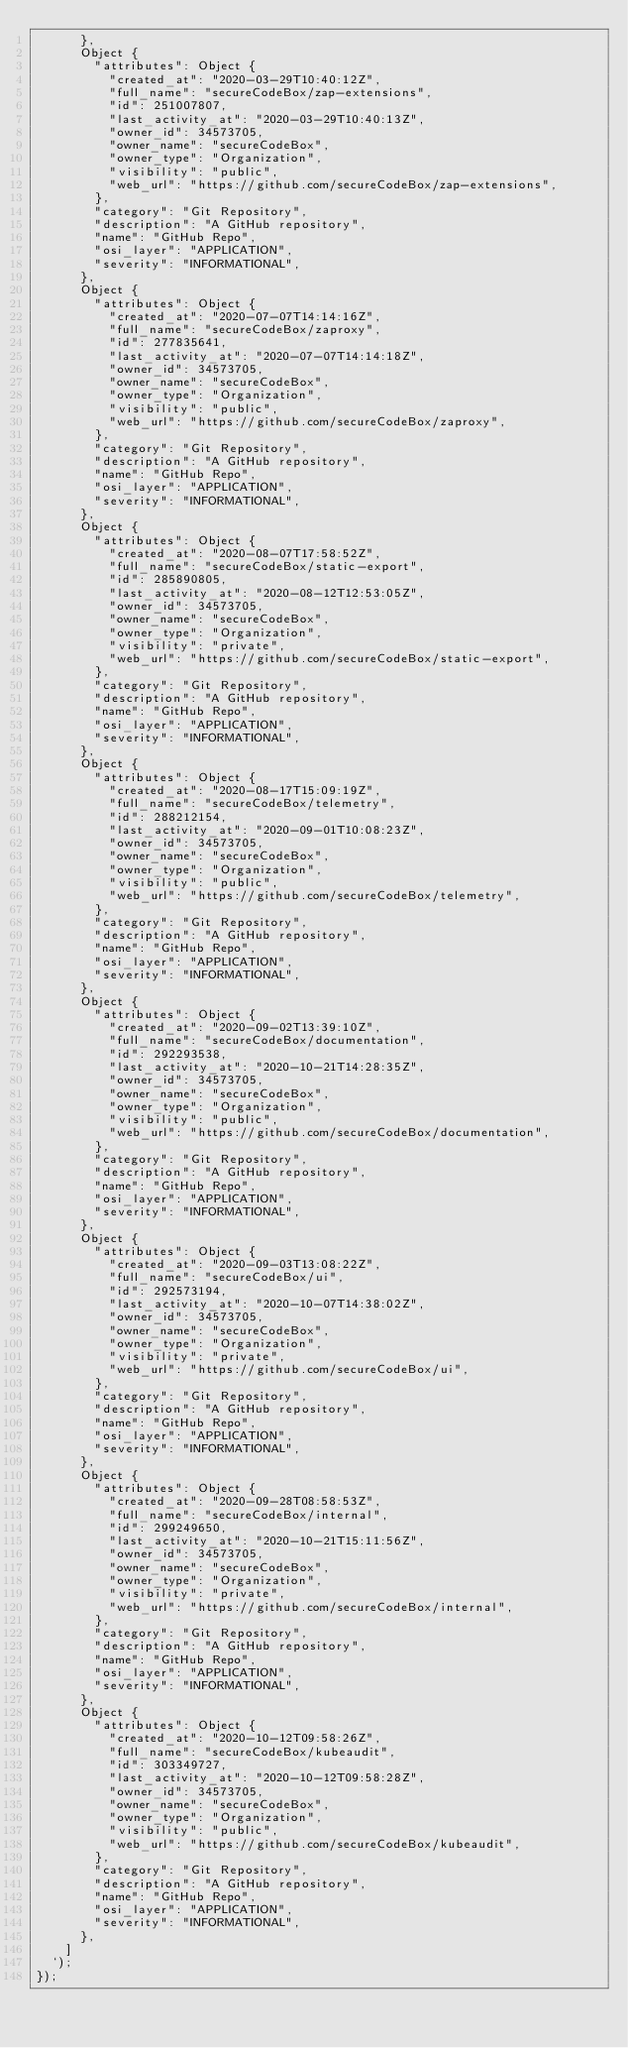Convert code to text. <code><loc_0><loc_0><loc_500><loc_500><_JavaScript_>      },
      Object {
        "attributes": Object {
          "created_at": "2020-03-29T10:40:12Z",
          "full_name": "secureCodeBox/zap-extensions",
          "id": 251007807,
          "last_activity_at": "2020-03-29T10:40:13Z",
          "owner_id": 34573705,
          "owner_name": "secureCodeBox",
          "owner_type": "Organization",
          "visibility": "public",
          "web_url": "https://github.com/secureCodeBox/zap-extensions",
        },
        "category": "Git Repository",
        "description": "A GitHub repository",
        "name": "GitHub Repo",
        "osi_layer": "APPLICATION",
        "severity": "INFORMATIONAL",
      },
      Object {
        "attributes": Object {
          "created_at": "2020-07-07T14:14:16Z",
          "full_name": "secureCodeBox/zaproxy",
          "id": 277835641,
          "last_activity_at": "2020-07-07T14:14:18Z",
          "owner_id": 34573705,
          "owner_name": "secureCodeBox",
          "owner_type": "Organization",
          "visibility": "public",
          "web_url": "https://github.com/secureCodeBox/zaproxy",
        },
        "category": "Git Repository",
        "description": "A GitHub repository",
        "name": "GitHub Repo",
        "osi_layer": "APPLICATION",
        "severity": "INFORMATIONAL",
      },
      Object {
        "attributes": Object {
          "created_at": "2020-08-07T17:58:52Z",
          "full_name": "secureCodeBox/static-export",
          "id": 285890805,
          "last_activity_at": "2020-08-12T12:53:05Z",
          "owner_id": 34573705,
          "owner_name": "secureCodeBox",
          "owner_type": "Organization",
          "visibility": "private",
          "web_url": "https://github.com/secureCodeBox/static-export",
        },
        "category": "Git Repository",
        "description": "A GitHub repository",
        "name": "GitHub Repo",
        "osi_layer": "APPLICATION",
        "severity": "INFORMATIONAL",
      },
      Object {
        "attributes": Object {
          "created_at": "2020-08-17T15:09:19Z",
          "full_name": "secureCodeBox/telemetry",
          "id": 288212154,
          "last_activity_at": "2020-09-01T10:08:23Z",
          "owner_id": 34573705,
          "owner_name": "secureCodeBox",
          "owner_type": "Organization",
          "visibility": "public",
          "web_url": "https://github.com/secureCodeBox/telemetry",
        },
        "category": "Git Repository",
        "description": "A GitHub repository",
        "name": "GitHub Repo",
        "osi_layer": "APPLICATION",
        "severity": "INFORMATIONAL",
      },
      Object {
        "attributes": Object {
          "created_at": "2020-09-02T13:39:10Z",
          "full_name": "secureCodeBox/documentation",
          "id": 292293538,
          "last_activity_at": "2020-10-21T14:28:35Z",
          "owner_id": 34573705,
          "owner_name": "secureCodeBox",
          "owner_type": "Organization",
          "visibility": "public",
          "web_url": "https://github.com/secureCodeBox/documentation",
        },
        "category": "Git Repository",
        "description": "A GitHub repository",
        "name": "GitHub Repo",
        "osi_layer": "APPLICATION",
        "severity": "INFORMATIONAL",
      },
      Object {
        "attributes": Object {
          "created_at": "2020-09-03T13:08:22Z",
          "full_name": "secureCodeBox/ui",
          "id": 292573194,
          "last_activity_at": "2020-10-07T14:38:02Z",
          "owner_id": 34573705,
          "owner_name": "secureCodeBox",
          "owner_type": "Organization",
          "visibility": "private",
          "web_url": "https://github.com/secureCodeBox/ui",
        },
        "category": "Git Repository",
        "description": "A GitHub repository",
        "name": "GitHub Repo",
        "osi_layer": "APPLICATION",
        "severity": "INFORMATIONAL",
      },
      Object {
        "attributes": Object {
          "created_at": "2020-09-28T08:58:53Z",
          "full_name": "secureCodeBox/internal",
          "id": 299249650,
          "last_activity_at": "2020-10-21T15:11:56Z",
          "owner_id": 34573705,
          "owner_name": "secureCodeBox",
          "owner_type": "Organization",
          "visibility": "private",
          "web_url": "https://github.com/secureCodeBox/internal",
        },
        "category": "Git Repository",
        "description": "A GitHub repository",
        "name": "GitHub Repo",
        "osi_layer": "APPLICATION",
        "severity": "INFORMATIONAL",
      },
      Object {
        "attributes": Object {
          "created_at": "2020-10-12T09:58:26Z",
          "full_name": "secureCodeBox/kubeaudit",
          "id": 303349727,
          "last_activity_at": "2020-10-12T09:58:28Z",
          "owner_id": 34573705,
          "owner_name": "secureCodeBox",
          "owner_type": "Organization",
          "visibility": "public",
          "web_url": "https://github.com/secureCodeBox/kubeaudit",
        },
        "category": "Git Repository",
        "description": "A GitHub repository",
        "name": "GitHub Repo",
        "osi_layer": "APPLICATION",
        "severity": "INFORMATIONAL",
      },
    ]
  `);
});
</code> 